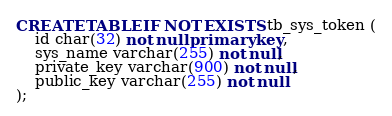<code> <loc_0><loc_0><loc_500><loc_500><_SQL_>CREATE TABLE IF NOT EXISTS tb_sys_token (
    id char(32) not null primary key,
    sys_name varchar(255) not null,
    private_key varchar(900) not null,
    public_key varchar(255) not null
);</code> 